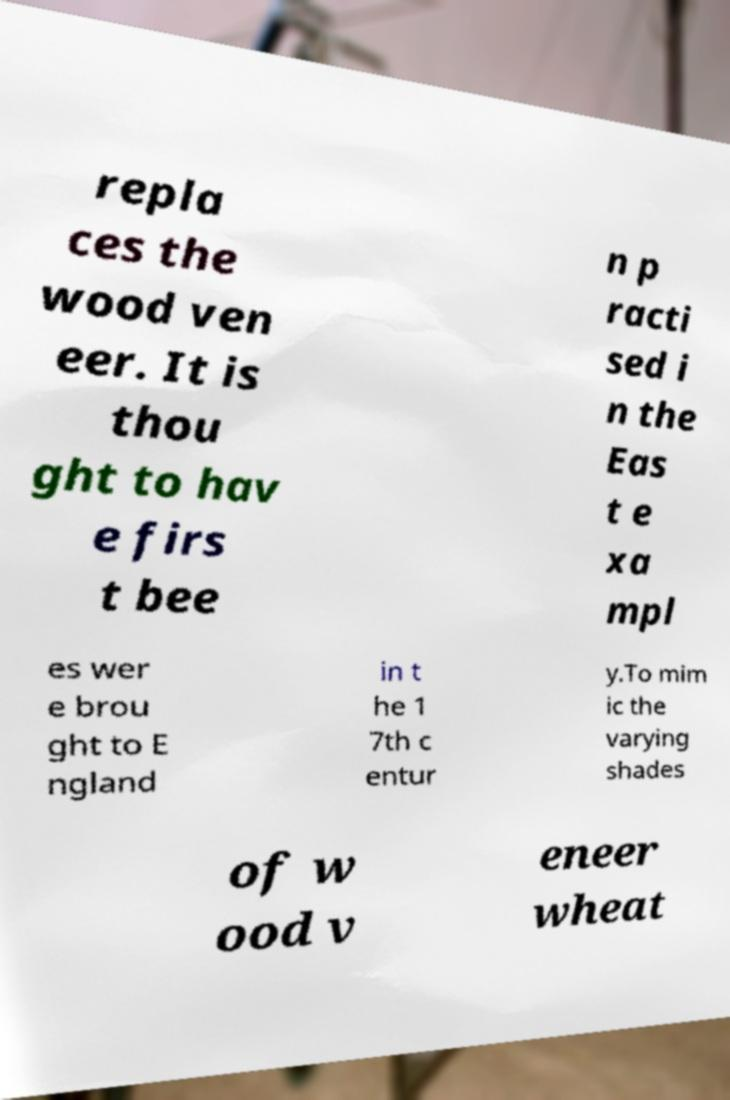Please read and relay the text visible in this image. What does it say? repla ces the wood ven eer. It is thou ght to hav e firs t bee n p racti sed i n the Eas t e xa mpl es wer e brou ght to E ngland in t he 1 7th c entur y.To mim ic the varying shades of w ood v eneer wheat 